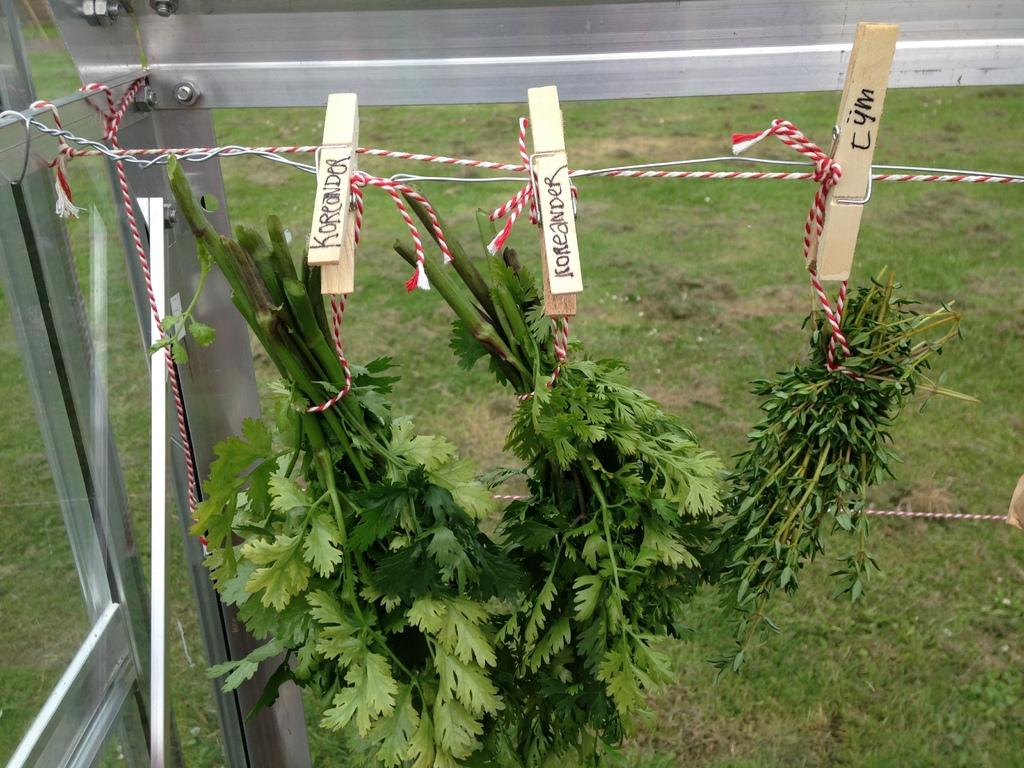Provide a one-sentence caption for the provided image. The clothespins holding the herbs are labeled with the type of herb it is. 